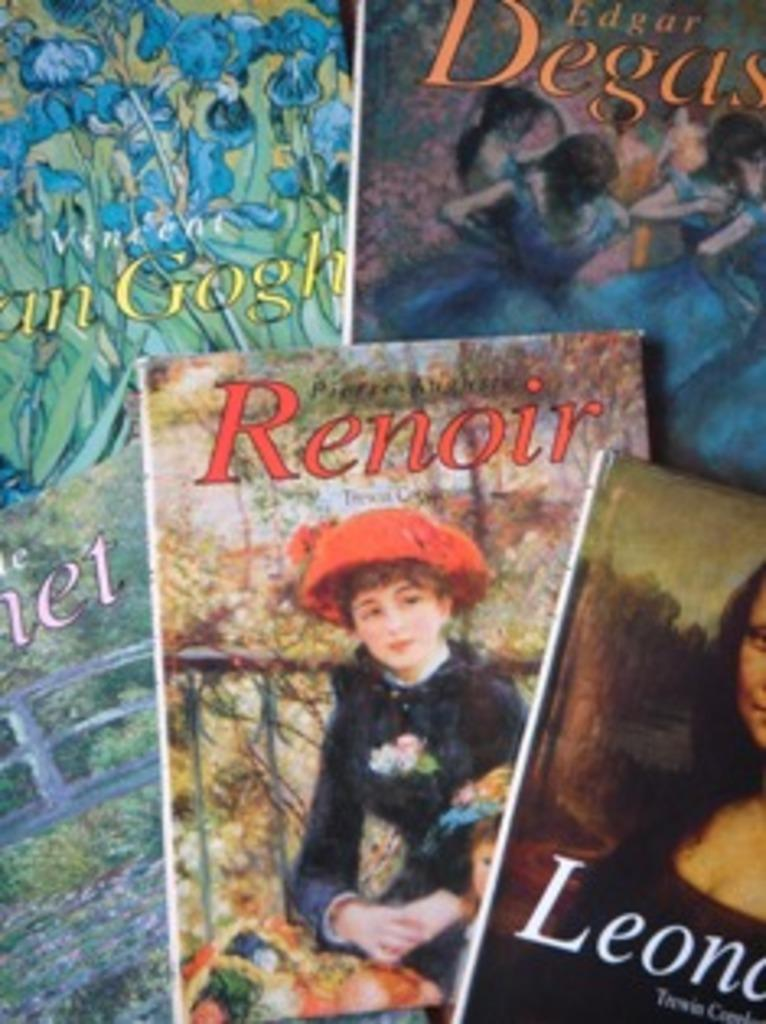<image>
Offer a succinct explanation of the picture presented. A group of art books piled together depicting Renoir and other artists. 